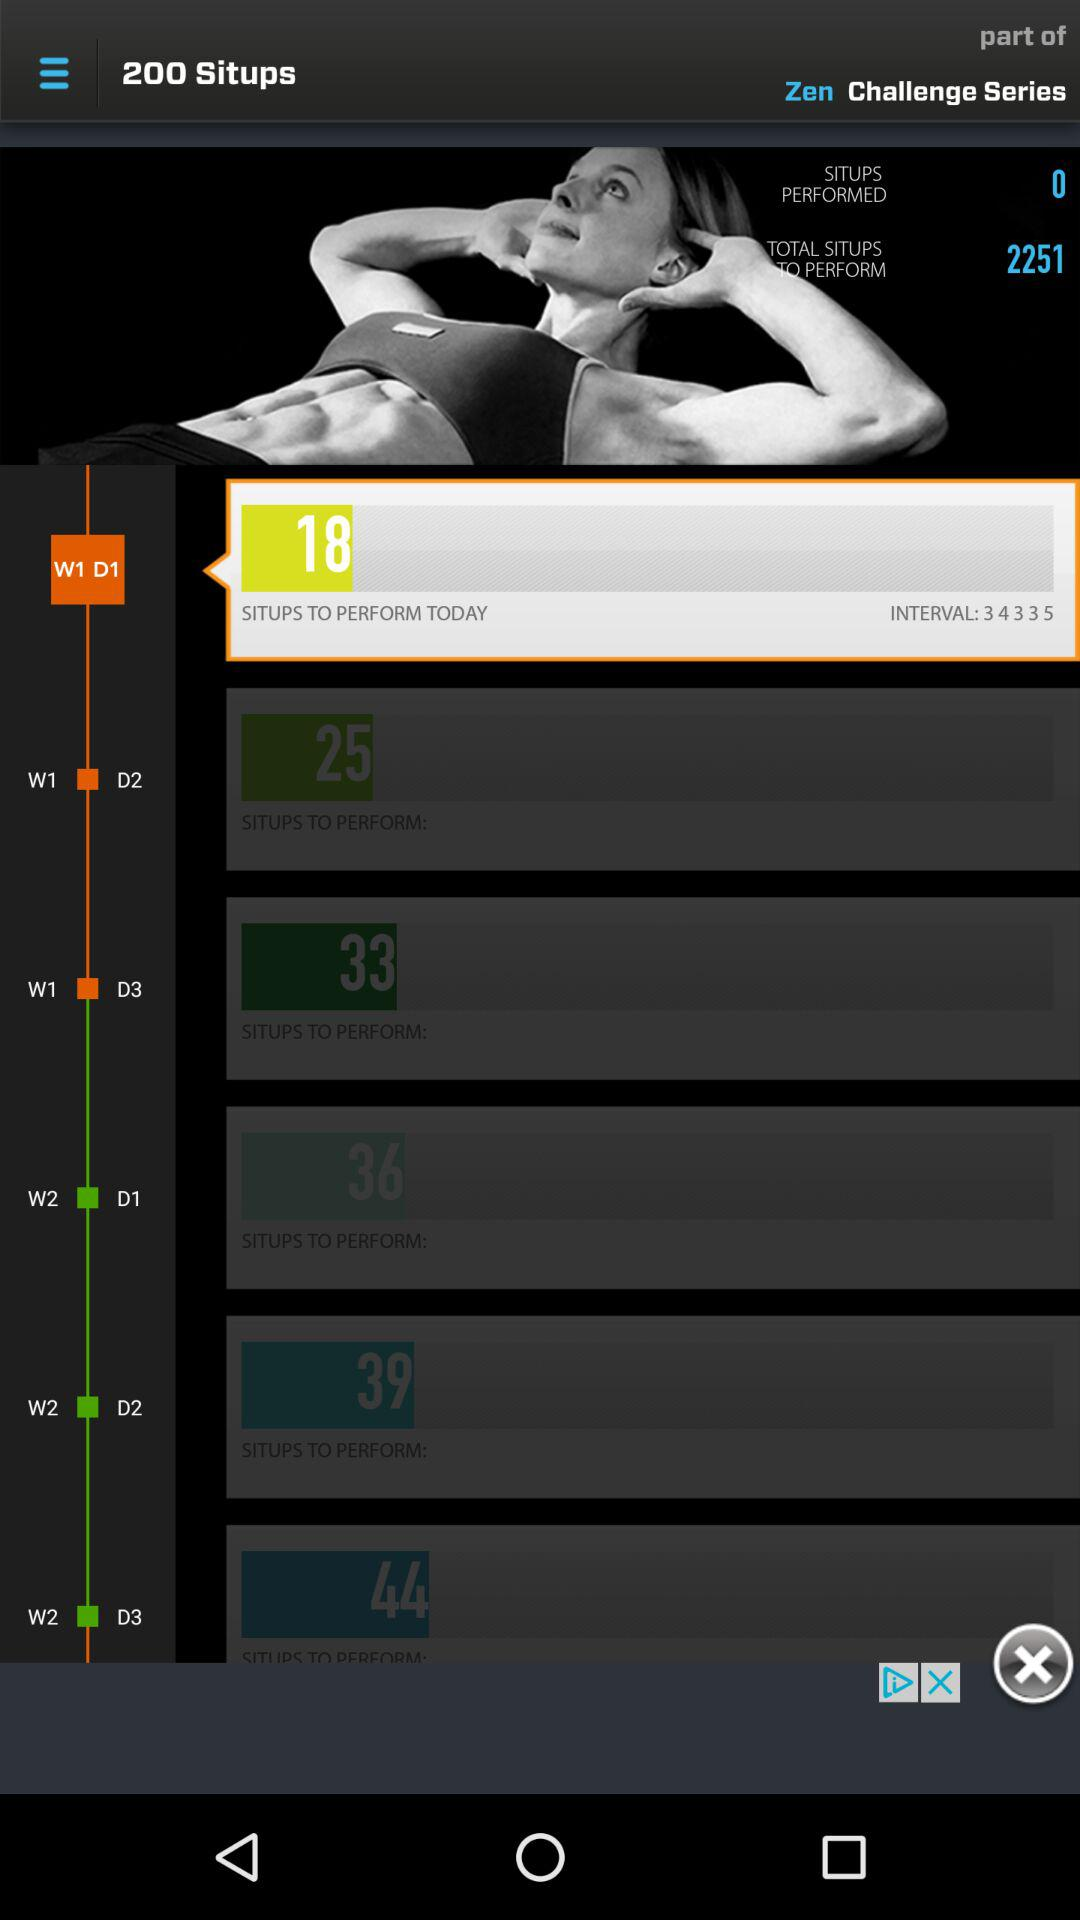How many situps are there in total on this page?
Answer the question using a single word or phrase. 2251 